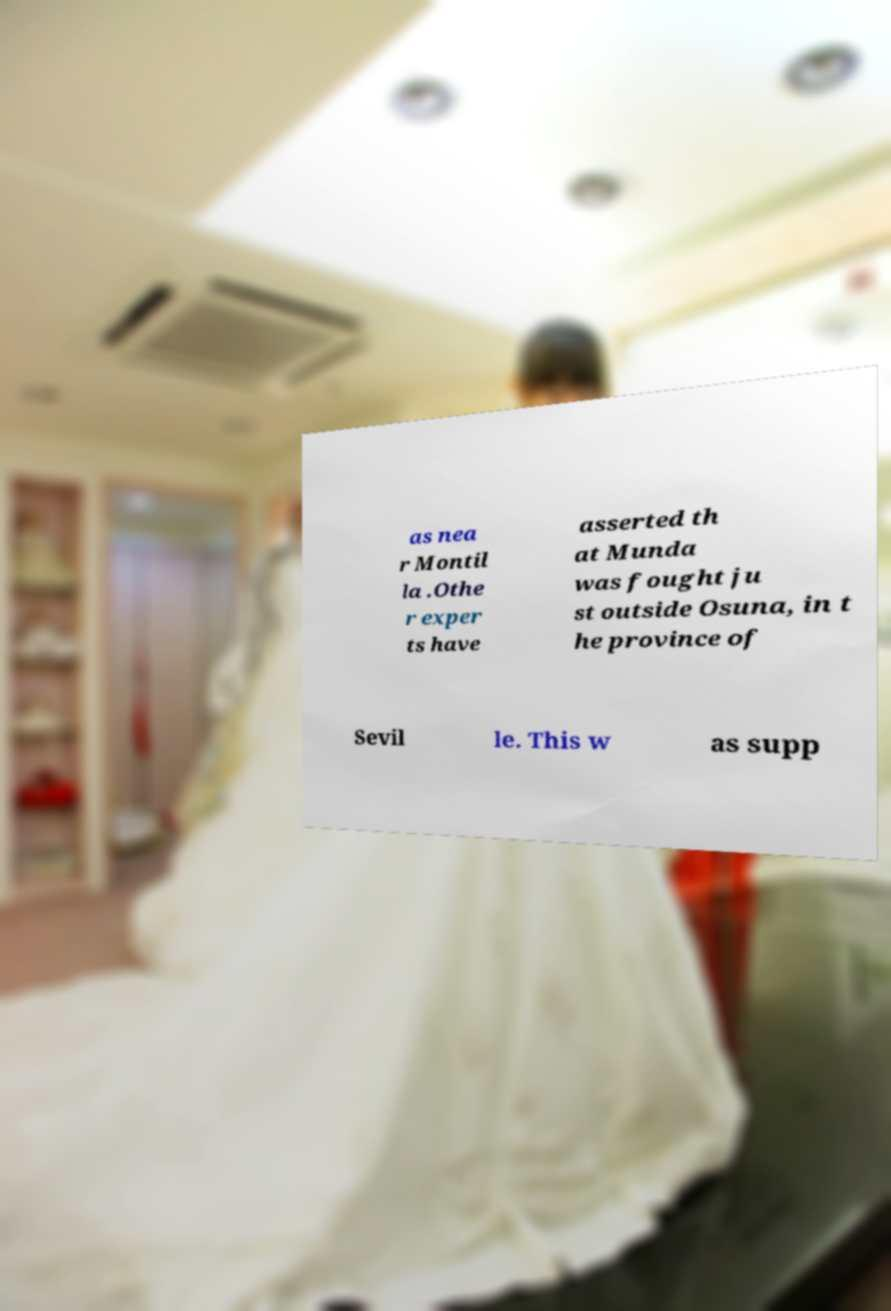Can you accurately transcribe the text from the provided image for me? as nea r Montil la .Othe r exper ts have asserted th at Munda was fought ju st outside Osuna, in t he province of Sevil le. This w as supp 